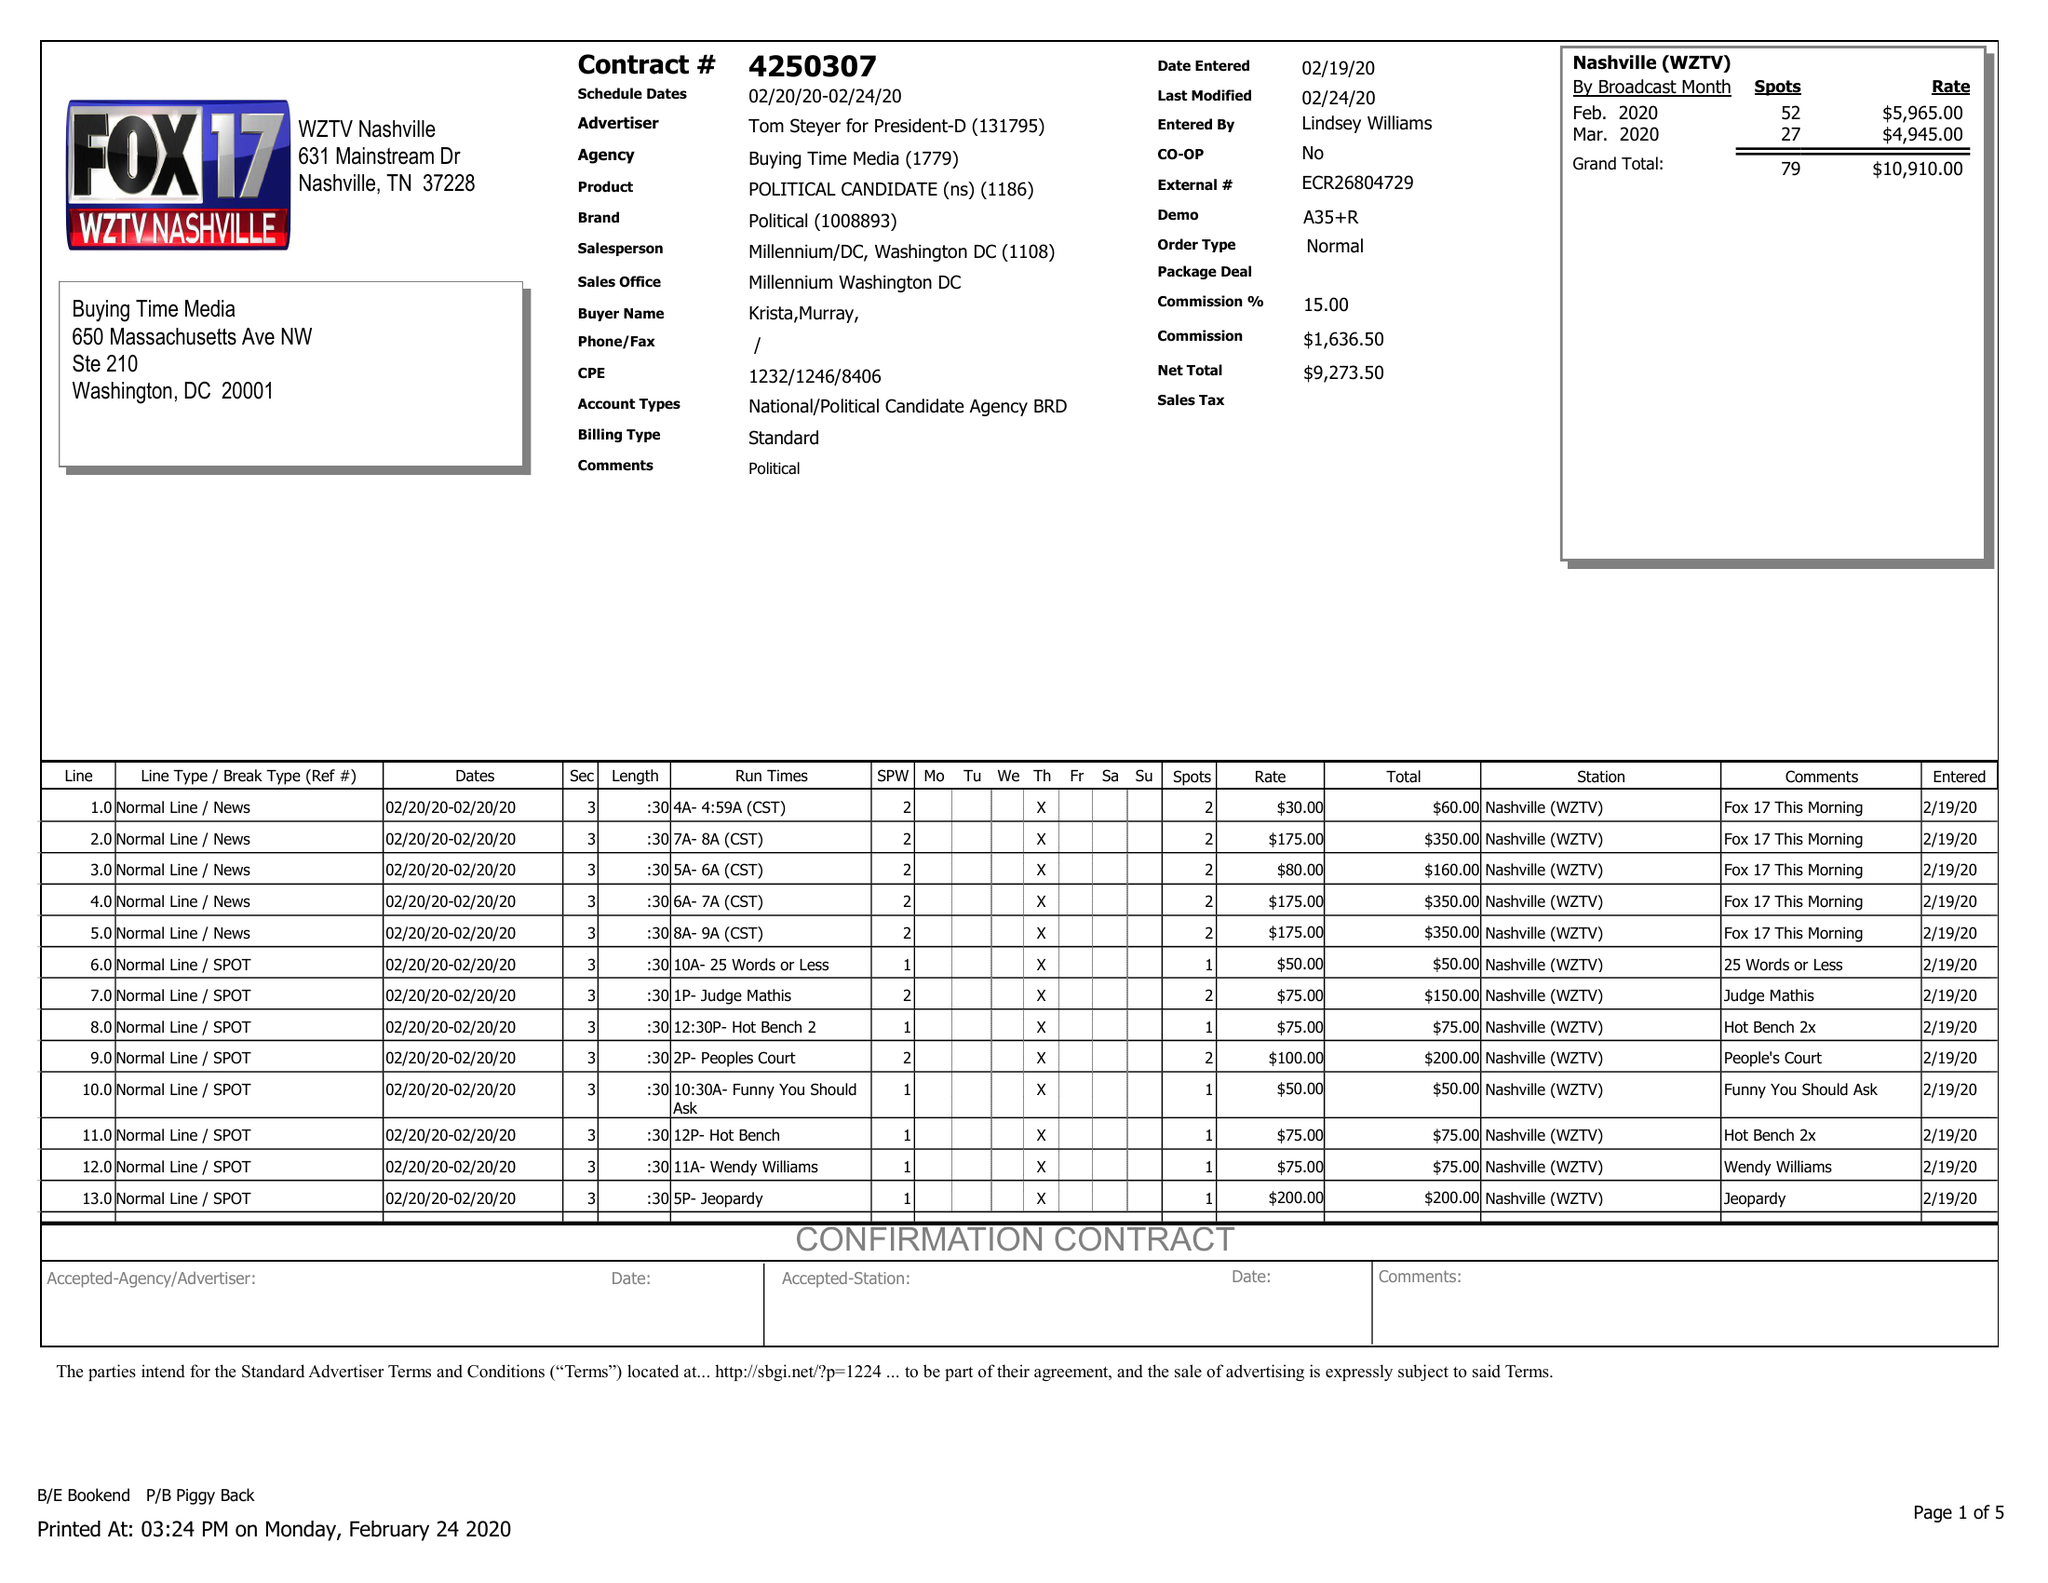What is the value for the advertiser?
Answer the question using a single word or phrase. TOM STEYER FOR PRESIDENT-D 